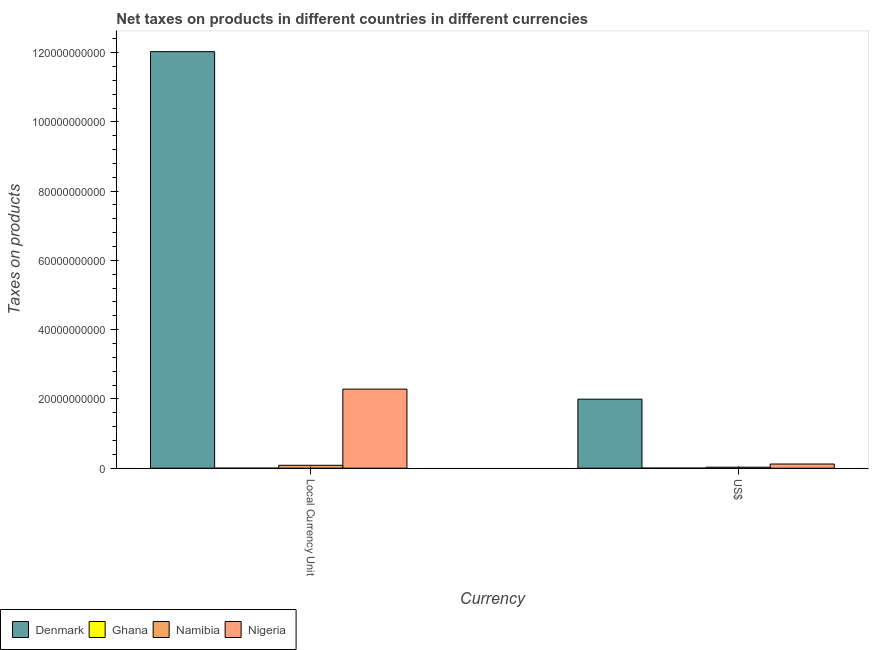How many different coloured bars are there?
Provide a succinct answer. 4. How many groups of bars are there?
Your answer should be compact. 2. Are the number of bars per tick equal to the number of legend labels?
Ensure brevity in your answer.  Yes. Are the number of bars on each tick of the X-axis equal?
Your answer should be compact. Yes. How many bars are there on the 1st tick from the left?
Provide a short and direct response. 4. How many bars are there on the 2nd tick from the right?
Give a very brief answer. 4. What is the label of the 2nd group of bars from the left?
Provide a succinct answer. US$. What is the net taxes in constant 2005 us$ in Ghana?
Your answer should be compact. 1.15e+06. Across all countries, what is the maximum net taxes in us$?
Offer a very short reply. 1.99e+1. Across all countries, what is the minimum net taxes in us$?
Provide a short and direct response. 2.63e+07. In which country was the net taxes in us$ maximum?
Make the answer very short. Denmark. In which country was the net taxes in us$ minimum?
Your answer should be very brief. Ghana. What is the total net taxes in constant 2005 us$ in the graph?
Your response must be concise. 1.44e+11. What is the difference between the net taxes in constant 2005 us$ in Namibia and that in Ghana?
Your answer should be very brief. 8.39e+08. What is the difference between the net taxes in us$ in Ghana and the net taxes in constant 2005 us$ in Denmark?
Keep it short and to the point. -1.20e+11. What is the average net taxes in us$ per country?
Provide a succinct answer. 5.36e+09. What is the difference between the net taxes in constant 2005 us$ and net taxes in us$ in Ghana?
Your answer should be very brief. -2.52e+07. What is the ratio of the net taxes in us$ in Nigeria to that in Denmark?
Provide a short and direct response. 0.06. Is the net taxes in us$ in Ghana less than that in Namibia?
Offer a very short reply. Yes. In how many countries, is the net taxes in us$ greater than the average net taxes in us$ taken over all countries?
Give a very brief answer. 1. What does the 3rd bar from the left in Local Currency Unit represents?
Offer a very short reply. Namibia. What does the 1st bar from the right in US$ represents?
Keep it short and to the point. Nigeria. Are all the bars in the graph horizontal?
Keep it short and to the point. No. How many countries are there in the graph?
Your response must be concise. 4. Does the graph contain any zero values?
Provide a succinct answer. No. How are the legend labels stacked?
Your response must be concise. Horizontal. What is the title of the graph?
Your answer should be compact. Net taxes on products in different countries in different currencies. What is the label or title of the X-axis?
Your answer should be very brief. Currency. What is the label or title of the Y-axis?
Make the answer very short. Taxes on products. What is the Taxes on products in Denmark in Local Currency Unit?
Provide a succinct answer. 1.20e+11. What is the Taxes on products in Ghana in Local Currency Unit?
Provide a succinct answer. 1.15e+06. What is the Taxes on products in Namibia in Local Currency Unit?
Your answer should be compact. 8.40e+08. What is the Taxes on products in Nigeria in Local Currency Unit?
Ensure brevity in your answer.  2.28e+1. What is the Taxes on products of Denmark in US$?
Provide a succinct answer. 1.99e+1. What is the Taxes on products in Ghana in US$?
Keep it short and to the point. 2.63e+07. What is the Taxes on products in Namibia in US$?
Your answer should be compact. 2.94e+08. What is the Taxes on products of Nigeria in US$?
Your response must be concise. 1.20e+09. Across all Currency, what is the maximum Taxes on products in Denmark?
Your answer should be very brief. 1.20e+11. Across all Currency, what is the maximum Taxes on products in Ghana?
Provide a short and direct response. 2.63e+07. Across all Currency, what is the maximum Taxes on products in Namibia?
Provide a short and direct response. 8.40e+08. Across all Currency, what is the maximum Taxes on products of Nigeria?
Provide a succinct answer. 2.28e+1. Across all Currency, what is the minimum Taxes on products in Denmark?
Your answer should be compact. 1.99e+1. Across all Currency, what is the minimum Taxes on products in Ghana?
Provide a short and direct response. 1.15e+06. Across all Currency, what is the minimum Taxes on products in Namibia?
Your answer should be compact. 2.94e+08. Across all Currency, what is the minimum Taxes on products in Nigeria?
Give a very brief answer. 1.20e+09. What is the total Taxes on products in Denmark in the graph?
Provide a short and direct response. 1.40e+11. What is the total Taxes on products of Ghana in the graph?
Provide a short and direct response. 2.75e+07. What is the total Taxes on products of Namibia in the graph?
Give a very brief answer. 1.13e+09. What is the total Taxes on products of Nigeria in the graph?
Provide a short and direct response. 2.40e+1. What is the difference between the Taxes on products in Denmark in Local Currency Unit and that in US$?
Provide a short and direct response. 1.00e+11. What is the difference between the Taxes on products in Ghana in Local Currency Unit and that in US$?
Ensure brevity in your answer.  -2.52e+07. What is the difference between the Taxes on products of Namibia in Local Currency Unit and that in US$?
Make the answer very short. 5.45e+08. What is the difference between the Taxes on products of Nigeria in Local Currency Unit and that in US$?
Offer a very short reply. 2.16e+1. What is the difference between the Taxes on products in Denmark in Local Currency Unit and the Taxes on products in Ghana in US$?
Offer a very short reply. 1.20e+11. What is the difference between the Taxes on products of Denmark in Local Currency Unit and the Taxes on products of Namibia in US$?
Make the answer very short. 1.20e+11. What is the difference between the Taxes on products of Denmark in Local Currency Unit and the Taxes on products of Nigeria in US$?
Make the answer very short. 1.19e+11. What is the difference between the Taxes on products in Ghana in Local Currency Unit and the Taxes on products in Namibia in US$?
Ensure brevity in your answer.  -2.93e+08. What is the difference between the Taxes on products of Ghana in Local Currency Unit and the Taxes on products of Nigeria in US$?
Your answer should be very brief. -1.20e+09. What is the difference between the Taxes on products in Namibia in Local Currency Unit and the Taxes on products in Nigeria in US$?
Provide a short and direct response. -3.65e+08. What is the average Taxes on products in Denmark per Currency?
Provide a succinct answer. 7.01e+1. What is the average Taxes on products in Ghana per Currency?
Your answer should be compact. 1.37e+07. What is the average Taxes on products in Namibia per Currency?
Your answer should be compact. 5.67e+08. What is the average Taxes on products in Nigeria per Currency?
Give a very brief answer. 1.20e+1. What is the difference between the Taxes on products in Denmark and Taxes on products in Ghana in Local Currency Unit?
Make the answer very short. 1.20e+11. What is the difference between the Taxes on products in Denmark and Taxes on products in Namibia in Local Currency Unit?
Give a very brief answer. 1.19e+11. What is the difference between the Taxes on products in Denmark and Taxes on products in Nigeria in Local Currency Unit?
Your answer should be compact. 9.74e+1. What is the difference between the Taxes on products of Ghana and Taxes on products of Namibia in Local Currency Unit?
Your response must be concise. -8.39e+08. What is the difference between the Taxes on products in Ghana and Taxes on products in Nigeria in Local Currency Unit?
Provide a succinct answer. -2.28e+1. What is the difference between the Taxes on products in Namibia and Taxes on products in Nigeria in Local Currency Unit?
Provide a short and direct response. -2.20e+1. What is the difference between the Taxes on products in Denmark and Taxes on products in Ghana in US$?
Ensure brevity in your answer.  1.99e+1. What is the difference between the Taxes on products in Denmark and Taxes on products in Namibia in US$?
Your answer should be very brief. 1.96e+1. What is the difference between the Taxes on products of Denmark and Taxes on products of Nigeria in US$?
Ensure brevity in your answer.  1.87e+1. What is the difference between the Taxes on products in Ghana and Taxes on products in Namibia in US$?
Ensure brevity in your answer.  -2.68e+08. What is the difference between the Taxes on products of Ghana and Taxes on products of Nigeria in US$?
Make the answer very short. -1.18e+09. What is the difference between the Taxes on products in Namibia and Taxes on products in Nigeria in US$?
Provide a succinct answer. -9.10e+08. What is the ratio of the Taxes on products in Denmark in Local Currency Unit to that in US$?
Your answer should be compact. 6.04. What is the ratio of the Taxes on products in Ghana in Local Currency Unit to that in US$?
Provide a succinct answer. 0.04. What is the ratio of the Taxes on products of Namibia in Local Currency Unit to that in US$?
Provide a short and direct response. 2.85. What is the ratio of the Taxes on products of Nigeria in Local Currency Unit to that in US$?
Give a very brief answer. 18.96. What is the difference between the highest and the second highest Taxes on products of Denmark?
Ensure brevity in your answer.  1.00e+11. What is the difference between the highest and the second highest Taxes on products of Ghana?
Give a very brief answer. 2.52e+07. What is the difference between the highest and the second highest Taxes on products in Namibia?
Provide a succinct answer. 5.45e+08. What is the difference between the highest and the second highest Taxes on products in Nigeria?
Offer a very short reply. 2.16e+1. What is the difference between the highest and the lowest Taxes on products in Denmark?
Your answer should be compact. 1.00e+11. What is the difference between the highest and the lowest Taxes on products in Ghana?
Your answer should be very brief. 2.52e+07. What is the difference between the highest and the lowest Taxes on products of Namibia?
Your answer should be very brief. 5.45e+08. What is the difference between the highest and the lowest Taxes on products of Nigeria?
Your answer should be compact. 2.16e+1. 